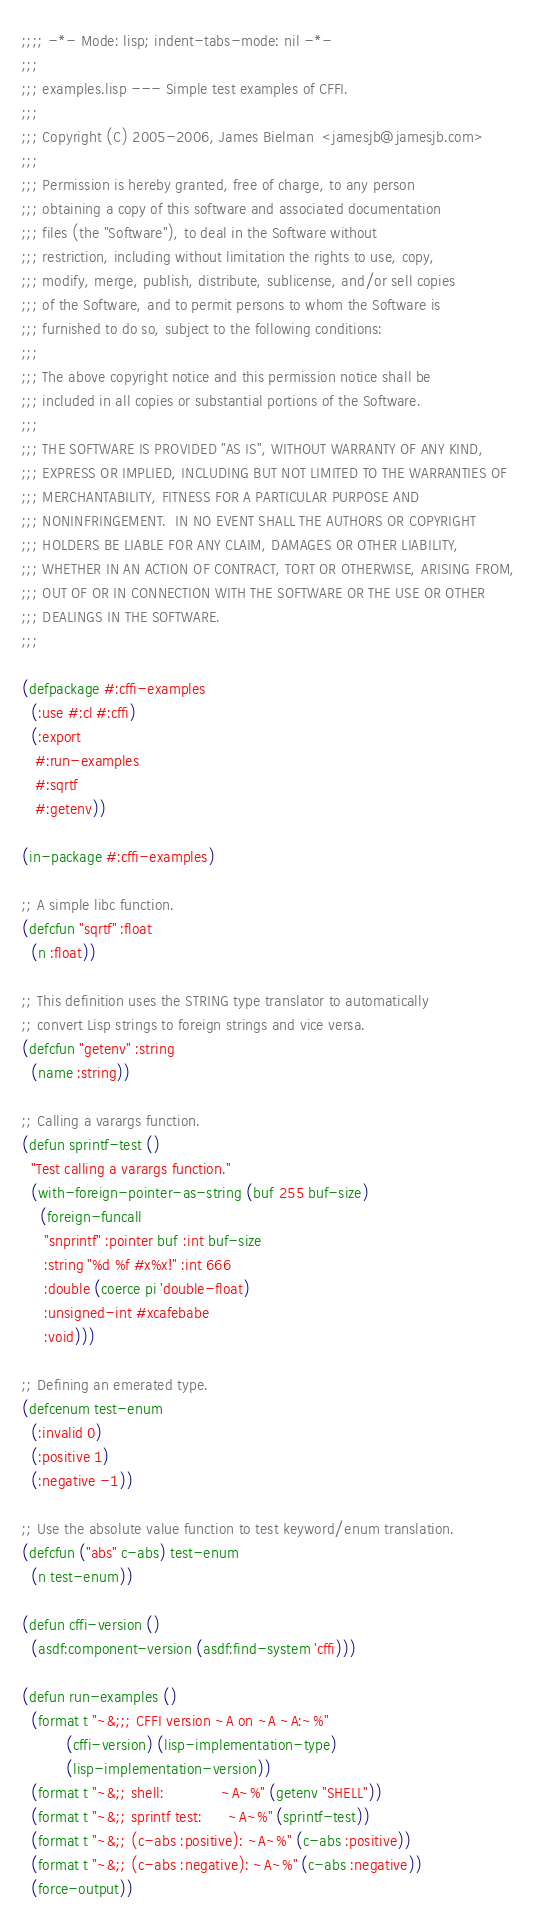<code> <loc_0><loc_0><loc_500><loc_500><_Lisp_>;;;; -*- Mode: lisp; indent-tabs-mode: nil -*-
;;;
;;; examples.lisp --- Simple test examples of CFFI.
;;;
;;; Copyright (C) 2005-2006, James Bielman  <jamesjb@jamesjb.com>
;;;
;;; Permission is hereby granted, free of charge, to any person
;;; obtaining a copy of this software and associated documentation
;;; files (the "Software"), to deal in the Software without
;;; restriction, including without limitation the rights to use, copy,
;;; modify, merge, publish, distribute, sublicense, and/or sell copies
;;; of the Software, and to permit persons to whom the Software is
;;; furnished to do so, subject to the following conditions:
;;;
;;; The above copyright notice and this permission notice shall be
;;; included in all copies or substantial portions of the Software.
;;;
;;; THE SOFTWARE IS PROVIDED "AS IS", WITHOUT WARRANTY OF ANY KIND,
;;; EXPRESS OR IMPLIED, INCLUDING BUT NOT LIMITED TO THE WARRANTIES OF
;;; MERCHANTABILITY, FITNESS FOR A PARTICULAR PURPOSE AND
;;; NONINFRINGEMENT.  IN NO EVENT SHALL THE AUTHORS OR COPYRIGHT
;;; HOLDERS BE LIABLE FOR ANY CLAIM, DAMAGES OR OTHER LIABILITY,
;;; WHETHER IN AN ACTION OF CONTRACT, TORT OR OTHERWISE, ARISING FROM,
;;; OUT OF OR IN CONNECTION WITH THE SOFTWARE OR THE USE OR OTHER
;;; DEALINGS IN THE SOFTWARE.
;;;

(defpackage #:cffi-examples
  (:use #:cl #:cffi)
  (:export
   #:run-examples
   #:sqrtf
   #:getenv))

(in-package #:cffi-examples)

;; A simple libc function.
(defcfun "sqrtf" :float
  (n :float))

;; This definition uses the STRING type translator to automatically
;; convert Lisp strings to foreign strings and vice versa.
(defcfun "getenv" :string
  (name :string))

;; Calling a varargs function.
(defun sprintf-test ()
  "Test calling a varargs function."
  (with-foreign-pointer-as-string (buf 255 buf-size)
    (foreign-funcall
     "snprintf" :pointer buf :int buf-size
     :string "%d %f #x%x!" :int 666
     :double (coerce pi 'double-float)
     :unsigned-int #xcafebabe
     :void)))

;; Defining an emerated type.
(defcenum test-enum
  (:invalid 0)
  (:positive 1)
  (:negative -1))

;; Use the absolute value function to test keyword/enum translation.
(defcfun ("abs" c-abs) test-enum
  (n test-enum))

(defun cffi-version ()
  (asdf:component-version (asdf:find-system 'cffi)))

(defun run-examples ()
  (format t "~&;;; CFFI version ~A on ~A ~A:~%"
          (cffi-version) (lisp-implementation-type)
          (lisp-implementation-version))
  (format t "~&;; shell:             ~A~%" (getenv "SHELL"))
  (format t "~&;; sprintf test:      ~A~%" (sprintf-test))
  (format t "~&;; (c-abs :positive): ~A~%" (c-abs :positive))
  (format t "~&;; (c-abs :negative): ~A~%" (c-abs :negative))
  (force-output))
</code> 